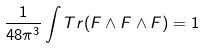Convert formula to latex. <formula><loc_0><loc_0><loc_500><loc_500>\frac { 1 } { 4 8 \pi ^ { 3 } } \int T r ( F \wedge F \wedge F ) = 1</formula> 